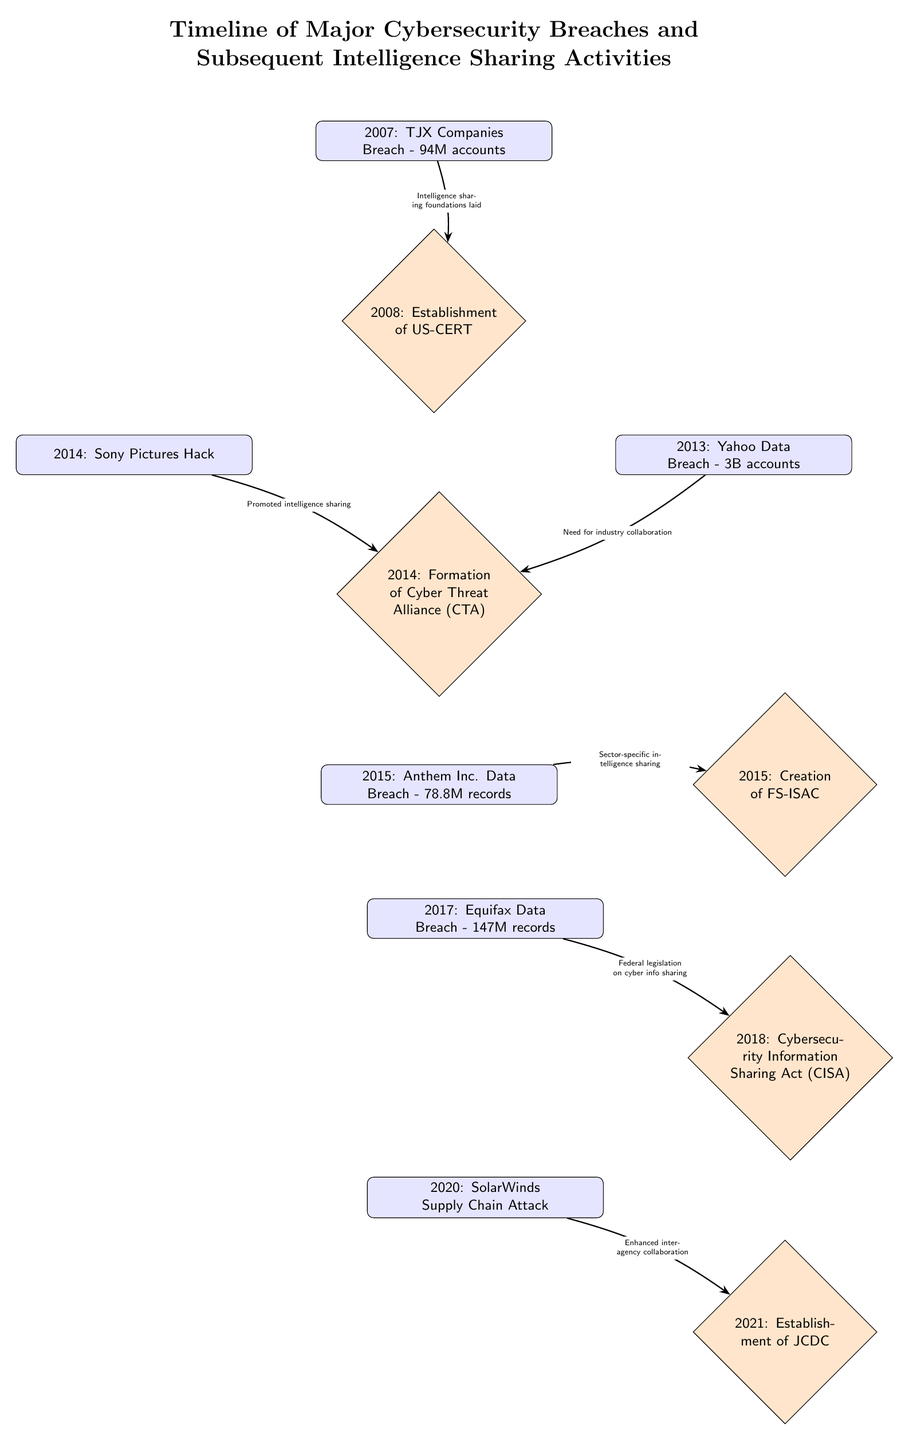What year did the TJX Companies breach occur? The diagram shows that the TJX Companies breach is the first event listed, which is labeled with the year 2007.
Answer: 2007 What is the total number of accounts affected by the Yahoo Data Breach? The diagram indicates that the Yahoo Data Breach impacted 3 billion accounts, as stated directly in the node for this event.
Answer: 3B accounts What is the relationship between the Sony Pictures Hack and the Cyber Threat Alliance (CTA)? The diagram indicates an arrow from the Sony Pictures Hack node to the Cyber Threat Alliance (CTA) node, labeled "Promoted intelligence sharing," indicating that the Sony Pictures Hack prompted the establishment of the CTA.
Answer: Promoted intelligence sharing How many intelligence sharing activities are listed below the breaches? Upon examining the diagram, there are six nodes classified as sharing activities, which are shown below different events in the timeline, confirming the count.
Answer: 6 What event triggered the creation of the FS-ISAC? The diagram shows an arrow from the Anthem Inc. Data Breach to the creation of the FS-ISAC, labeled "Sector-specific intelligence sharing," indicating that this breach triggered the FS-ISAC formation.
Answer: Anthem Inc. Data Breach What breakthrough in cyber intelligence sharing occurred in 2018? According to the diagram, the node labeled "Cybersecurity Information Sharing Act (CISA)" is positioned below the Equifax Data Breach event, indicating that this was a significant breakthrough in 2018.
Answer: Cybersecurity Information Sharing Act (CISA) What year did the SolarWinds Supply Chain Attack happen? The diagram lists the SolarWinds attack in the year 2020, clearly indicated in the respective event node.
Answer: 2020 Which organization was established in 2021 for improved intelligence sharing? The diagram specifies that the establishment of JCDC occurred in 2021, with this information directly depicted in its corresponding node.
Answer: JCDC 